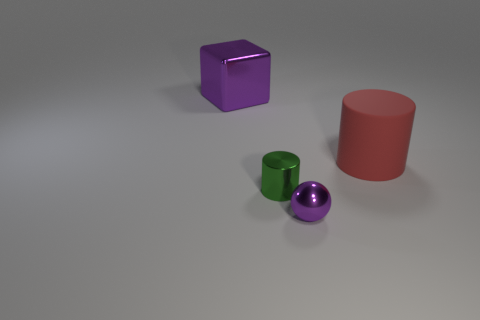Subtract all green cylinders. How many cylinders are left? 1 Subtract all spheres. How many objects are left? 3 Subtract 1 cylinders. How many cylinders are left? 1 Add 4 big purple shiny things. How many objects exist? 8 Subtract 0 gray cubes. How many objects are left? 4 Subtract all green balls. Subtract all brown cylinders. How many balls are left? 1 Subtract all brown cubes. How many yellow cylinders are left? 0 Subtract all purple metal objects. Subtract all large shiny things. How many objects are left? 1 Add 4 tiny things. How many tiny things are left? 6 Add 1 small green matte blocks. How many small green matte blocks exist? 1 